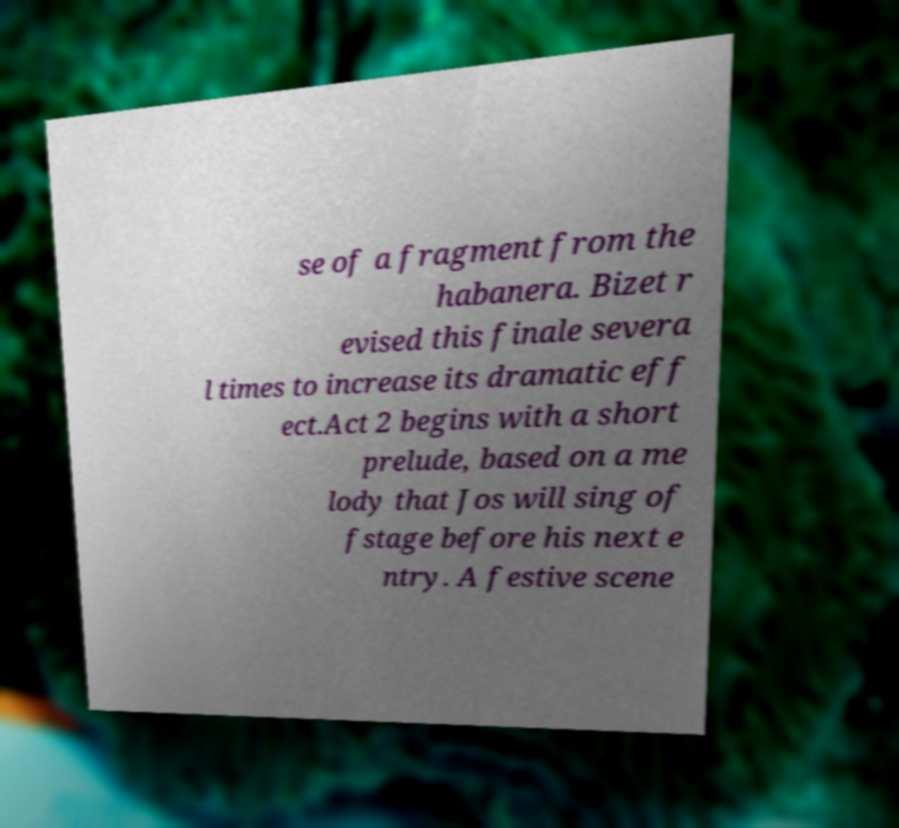There's text embedded in this image that I need extracted. Can you transcribe it verbatim? se of a fragment from the habanera. Bizet r evised this finale severa l times to increase its dramatic eff ect.Act 2 begins with a short prelude, based on a me lody that Jos will sing of fstage before his next e ntry. A festive scene 